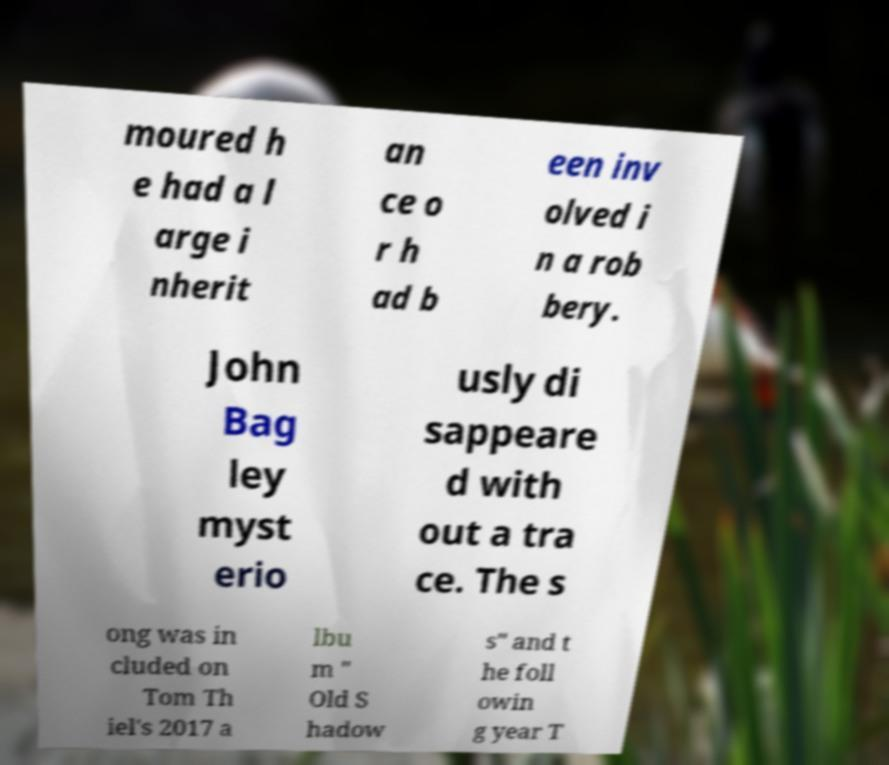Could you extract and type out the text from this image? moured h e had a l arge i nherit an ce o r h ad b een inv olved i n a rob bery. John Bag ley myst erio usly di sappeare d with out a tra ce. The s ong was in cluded on Tom Th iel's 2017 a lbu m " Old S hadow s" and t he foll owin g year T 